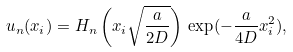<formula> <loc_0><loc_0><loc_500><loc_500>u _ { n } ( x _ { i } ) = H _ { n } \left ( x _ { i } \sqrt { \frac { a } { 2 D } } \right ) \, \exp ( - \frac { a } { 4 D } x _ { i } ^ { 2 } ) ,</formula> 